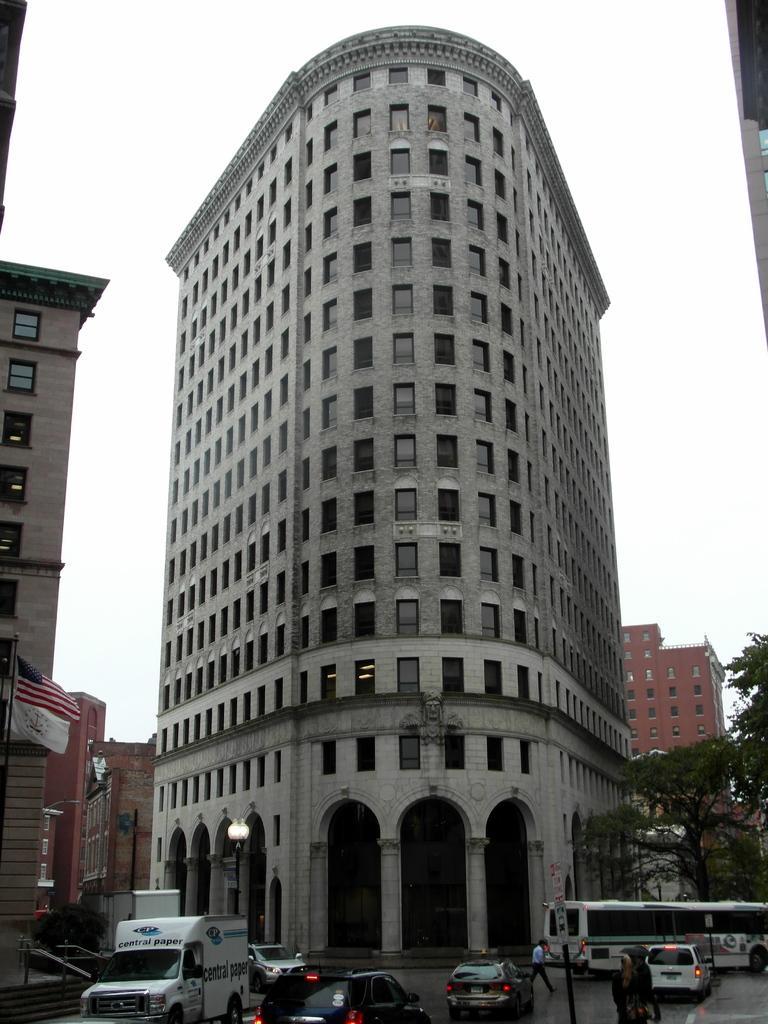Could you give a brief overview of what you see in this image? At the bottom of the image there are many vehicles and also there are poles with a sign board and lamps. Behind them there is a building with walls, windows, arches, pillars and doors. On the left corner of the image there is a building with walls, windows, steps and railings. And also there is a pole with a flag. On the right corner of the image there are trees. At the top of the image there is sky. 